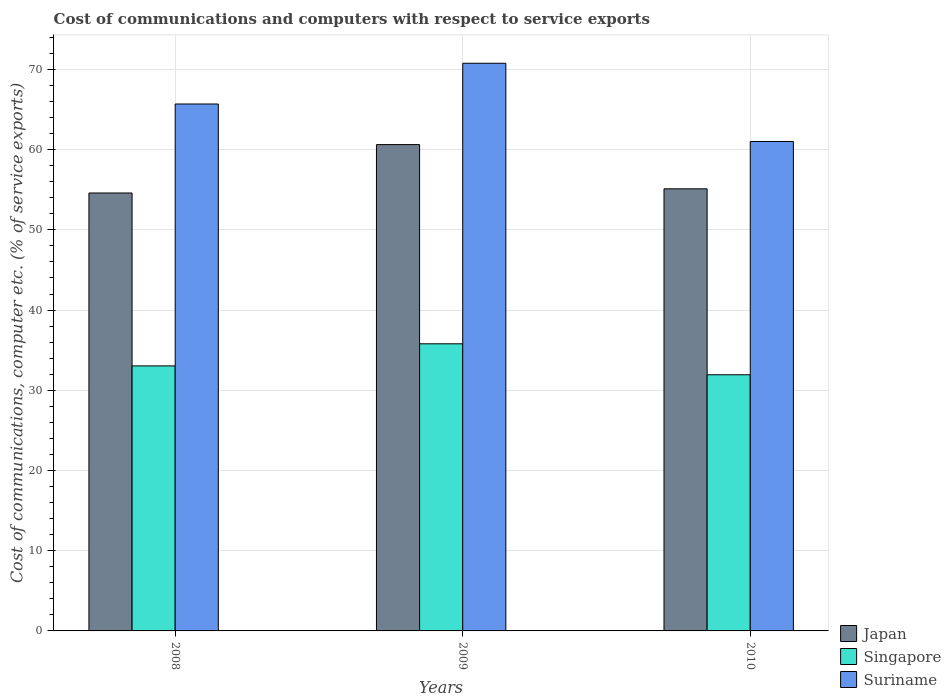How many different coloured bars are there?
Make the answer very short. 3. Are the number of bars on each tick of the X-axis equal?
Ensure brevity in your answer.  Yes. How many bars are there on the 2nd tick from the right?
Your answer should be very brief. 3. What is the cost of communications and computers in Singapore in 2009?
Provide a succinct answer. 35.8. Across all years, what is the maximum cost of communications and computers in Singapore?
Offer a terse response. 35.8. Across all years, what is the minimum cost of communications and computers in Japan?
Offer a terse response. 54.6. In which year was the cost of communications and computers in Singapore maximum?
Your answer should be very brief. 2009. In which year was the cost of communications and computers in Suriname minimum?
Your response must be concise. 2010. What is the total cost of communications and computers in Suriname in the graph?
Ensure brevity in your answer.  197.48. What is the difference between the cost of communications and computers in Singapore in 2008 and that in 2010?
Keep it short and to the point. 1.11. What is the difference between the cost of communications and computers in Singapore in 2008 and the cost of communications and computers in Japan in 2010?
Make the answer very short. -22.08. What is the average cost of communications and computers in Suriname per year?
Provide a succinct answer. 65.83. In the year 2009, what is the difference between the cost of communications and computers in Suriname and cost of communications and computers in Singapore?
Provide a succinct answer. 34.98. In how many years, is the cost of communications and computers in Japan greater than 68 %?
Your answer should be compact. 0. What is the ratio of the cost of communications and computers in Singapore in 2008 to that in 2010?
Provide a succinct answer. 1.03. Is the difference between the cost of communications and computers in Suriname in 2008 and 2010 greater than the difference between the cost of communications and computers in Singapore in 2008 and 2010?
Ensure brevity in your answer.  Yes. What is the difference between the highest and the second highest cost of communications and computers in Suriname?
Ensure brevity in your answer.  5.08. What is the difference between the highest and the lowest cost of communications and computers in Japan?
Keep it short and to the point. 6.03. In how many years, is the cost of communications and computers in Japan greater than the average cost of communications and computers in Japan taken over all years?
Give a very brief answer. 1. Is the sum of the cost of communications and computers in Suriname in 2008 and 2009 greater than the maximum cost of communications and computers in Japan across all years?
Provide a short and direct response. Yes. What does the 3rd bar from the right in 2010 represents?
Offer a very short reply. Japan. Is it the case that in every year, the sum of the cost of communications and computers in Singapore and cost of communications and computers in Suriname is greater than the cost of communications and computers in Japan?
Your answer should be very brief. Yes. Are all the bars in the graph horizontal?
Ensure brevity in your answer.  No. What is the difference between two consecutive major ticks on the Y-axis?
Your answer should be very brief. 10. Are the values on the major ticks of Y-axis written in scientific E-notation?
Your answer should be very brief. No. Does the graph contain grids?
Your response must be concise. Yes. How many legend labels are there?
Your answer should be compact. 3. What is the title of the graph?
Ensure brevity in your answer.  Cost of communications and computers with respect to service exports. Does "Tunisia" appear as one of the legend labels in the graph?
Your response must be concise. No. What is the label or title of the Y-axis?
Your response must be concise. Cost of communications, computer etc. (% of service exports). What is the Cost of communications, computer etc. (% of service exports) of Japan in 2008?
Ensure brevity in your answer.  54.6. What is the Cost of communications, computer etc. (% of service exports) in Singapore in 2008?
Offer a terse response. 33.04. What is the Cost of communications, computer etc. (% of service exports) in Suriname in 2008?
Give a very brief answer. 65.69. What is the Cost of communications, computer etc. (% of service exports) in Japan in 2009?
Provide a succinct answer. 60.63. What is the Cost of communications, computer etc. (% of service exports) in Singapore in 2009?
Offer a very short reply. 35.8. What is the Cost of communications, computer etc. (% of service exports) of Suriname in 2009?
Your response must be concise. 70.77. What is the Cost of communications, computer etc. (% of service exports) of Japan in 2010?
Provide a succinct answer. 55.12. What is the Cost of communications, computer etc. (% of service exports) of Singapore in 2010?
Your answer should be very brief. 31.93. What is the Cost of communications, computer etc. (% of service exports) in Suriname in 2010?
Your answer should be very brief. 61.02. Across all years, what is the maximum Cost of communications, computer etc. (% of service exports) of Japan?
Offer a very short reply. 60.63. Across all years, what is the maximum Cost of communications, computer etc. (% of service exports) of Singapore?
Provide a succinct answer. 35.8. Across all years, what is the maximum Cost of communications, computer etc. (% of service exports) in Suriname?
Give a very brief answer. 70.77. Across all years, what is the minimum Cost of communications, computer etc. (% of service exports) of Japan?
Provide a succinct answer. 54.6. Across all years, what is the minimum Cost of communications, computer etc. (% of service exports) of Singapore?
Offer a terse response. 31.93. Across all years, what is the minimum Cost of communications, computer etc. (% of service exports) of Suriname?
Provide a succinct answer. 61.02. What is the total Cost of communications, computer etc. (% of service exports) of Japan in the graph?
Provide a succinct answer. 170.34. What is the total Cost of communications, computer etc. (% of service exports) of Singapore in the graph?
Provide a short and direct response. 100.77. What is the total Cost of communications, computer etc. (% of service exports) in Suriname in the graph?
Your answer should be compact. 197.48. What is the difference between the Cost of communications, computer etc. (% of service exports) in Japan in 2008 and that in 2009?
Provide a succinct answer. -6.03. What is the difference between the Cost of communications, computer etc. (% of service exports) of Singapore in 2008 and that in 2009?
Keep it short and to the point. -2.75. What is the difference between the Cost of communications, computer etc. (% of service exports) in Suriname in 2008 and that in 2009?
Give a very brief answer. -5.08. What is the difference between the Cost of communications, computer etc. (% of service exports) of Japan in 2008 and that in 2010?
Make the answer very short. -0.52. What is the difference between the Cost of communications, computer etc. (% of service exports) in Singapore in 2008 and that in 2010?
Offer a very short reply. 1.11. What is the difference between the Cost of communications, computer etc. (% of service exports) of Suriname in 2008 and that in 2010?
Your response must be concise. 4.67. What is the difference between the Cost of communications, computer etc. (% of service exports) in Japan in 2009 and that in 2010?
Give a very brief answer. 5.51. What is the difference between the Cost of communications, computer etc. (% of service exports) in Singapore in 2009 and that in 2010?
Offer a very short reply. 3.86. What is the difference between the Cost of communications, computer etc. (% of service exports) in Suriname in 2009 and that in 2010?
Your answer should be very brief. 9.75. What is the difference between the Cost of communications, computer etc. (% of service exports) in Japan in 2008 and the Cost of communications, computer etc. (% of service exports) in Singapore in 2009?
Your response must be concise. 18.8. What is the difference between the Cost of communications, computer etc. (% of service exports) in Japan in 2008 and the Cost of communications, computer etc. (% of service exports) in Suriname in 2009?
Offer a terse response. -16.17. What is the difference between the Cost of communications, computer etc. (% of service exports) of Singapore in 2008 and the Cost of communications, computer etc. (% of service exports) of Suriname in 2009?
Provide a succinct answer. -37.73. What is the difference between the Cost of communications, computer etc. (% of service exports) of Japan in 2008 and the Cost of communications, computer etc. (% of service exports) of Singapore in 2010?
Offer a very short reply. 22.66. What is the difference between the Cost of communications, computer etc. (% of service exports) in Japan in 2008 and the Cost of communications, computer etc. (% of service exports) in Suriname in 2010?
Offer a very short reply. -6.42. What is the difference between the Cost of communications, computer etc. (% of service exports) in Singapore in 2008 and the Cost of communications, computer etc. (% of service exports) in Suriname in 2010?
Give a very brief answer. -27.98. What is the difference between the Cost of communications, computer etc. (% of service exports) of Japan in 2009 and the Cost of communications, computer etc. (% of service exports) of Singapore in 2010?
Your answer should be compact. 28.7. What is the difference between the Cost of communications, computer etc. (% of service exports) in Japan in 2009 and the Cost of communications, computer etc. (% of service exports) in Suriname in 2010?
Ensure brevity in your answer.  -0.39. What is the difference between the Cost of communications, computer etc. (% of service exports) in Singapore in 2009 and the Cost of communications, computer etc. (% of service exports) in Suriname in 2010?
Provide a succinct answer. -25.22. What is the average Cost of communications, computer etc. (% of service exports) in Japan per year?
Your response must be concise. 56.78. What is the average Cost of communications, computer etc. (% of service exports) of Singapore per year?
Your answer should be very brief. 33.59. What is the average Cost of communications, computer etc. (% of service exports) in Suriname per year?
Make the answer very short. 65.83. In the year 2008, what is the difference between the Cost of communications, computer etc. (% of service exports) of Japan and Cost of communications, computer etc. (% of service exports) of Singapore?
Provide a short and direct response. 21.56. In the year 2008, what is the difference between the Cost of communications, computer etc. (% of service exports) of Japan and Cost of communications, computer etc. (% of service exports) of Suriname?
Your response must be concise. -11.1. In the year 2008, what is the difference between the Cost of communications, computer etc. (% of service exports) of Singapore and Cost of communications, computer etc. (% of service exports) of Suriname?
Your answer should be compact. -32.65. In the year 2009, what is the difference between the Cost of communications, computer etc. (% of service exports) in Japan and Cost of communications, computer etc. (% of service exports) in Singapore?
Ensure brevity in your answer.  24.83. In the year 2009, what is the difference between the Cost of communications, computer etc. (% of service exports) of Japan and Cost of communications, computer etc. (% of service exports) of Suriname?
Your response must be concise. -10.14. In the year 2009, what is the difference between the Cost of communications, computer etc. (% of service exports) of Singapore and Cost of communications, computer etc. (% of service exports) of Suriname?
Provide a short and direct response. -34.98. In the year 2010, what is the difference between the Cost of communications, computer etc. (% of service exports) of Japan and Cost of communications, computer etc. (% of service exports) of Singapore?
Provide a short and direct response. 23.18. In the year 2010, what is the difference between the Cost of communications, computer etc. (% of service exports) of Japan and Cost of communications, computer etc. (% of service exports) of Suriname?
Your answer should be compact. -5.9. In the year 2010, what is the difference between the Cost of communications, computer etc. (% of service exports) of Singapore and Cost of communications, computer etc. (% of service exports) of Suriname?
Offer a very short reply. -29.09. What is the ratio of the Cost of communications, computer etc. (% of service exports) of Japan in 2008 to that in 2009?
Provide a succinct answer. 0.9. What is the ratio of the Cost of communications, computer etc. (% of service exports) of Singapore in 2008 to that in 2009?
Make the answer very short. 0.92. What is the ratio of the Cost of communications, computer etc. (% of service exports) in Suriname in 2008 to that in 2009?
Offer a terse response. 0.93. What is the ratio of the Cost of communications, computer etc. (% of service exports) in Japan in 2008 to that in 2010?
Keep it short and to the point. 0.99. What is the ratio of the Cost of communications, computer etc. (% of service exports) of Singapore in 2008 to that in 2010?
Provide a short and direct response. 1.03. What is the ratio of the Cost of communications, computer etc. (% of service exports) of Suriname in 2008 to that in 2010?
Make the answer very short. 1.08. What is the ratio of the Cost of communications, computer etc. (% of service exports) of Japan in 2009 to that in 2010?
Ensure brevity in your answer.  1.1. What is the ratio of the Cost of communications, computer etc. (% of service exports) of Singapore in 2009 to that in 2010?
Give a very brief answer. 1.12. What is the ratio of the Cost of communications, computer etc. (% of service exports) in Suriname in 2009 to that in 2010?
Your answer should be compact. 1.16. What is the difference between the highest and the second highest Cost of communications, computer etc. (% of service exports) of Japan?
Ensure brevity in your answer.  5.51. What is the difference between the highest and the second highest Cost of communications, computer etc. (% of service exports) of Singapore?
Your answer should be compact. 2.75. What is the difference between the highest and the second highest Cost of communications, computer etc. (% of service exports) in Suriname?
Ensure brevity in your answer.  5.08. What is the difference between the highest and the lowest Cost of communications, computer etc. (% of service exports) in Japan?
Keep it short and to the point. 6.03. What is the difference between the highest and the lowest Cost of communications, computer etc. (% of service exports) of Singapore?
Ensure brevity in your answer.  3.86. What is the difference between the highest and the lowest Cost of communications, computer etc. (% of service exports) of Suriname?
Provide a short and direct response. 9.75. 